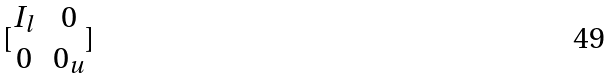<formula> <loc_0><loc_0><loc_500><loc_500>[ \begin{matrix} I _ { l } & 0 \\ 0 & 0 _ { u } \end{matrix} ]</formula> 